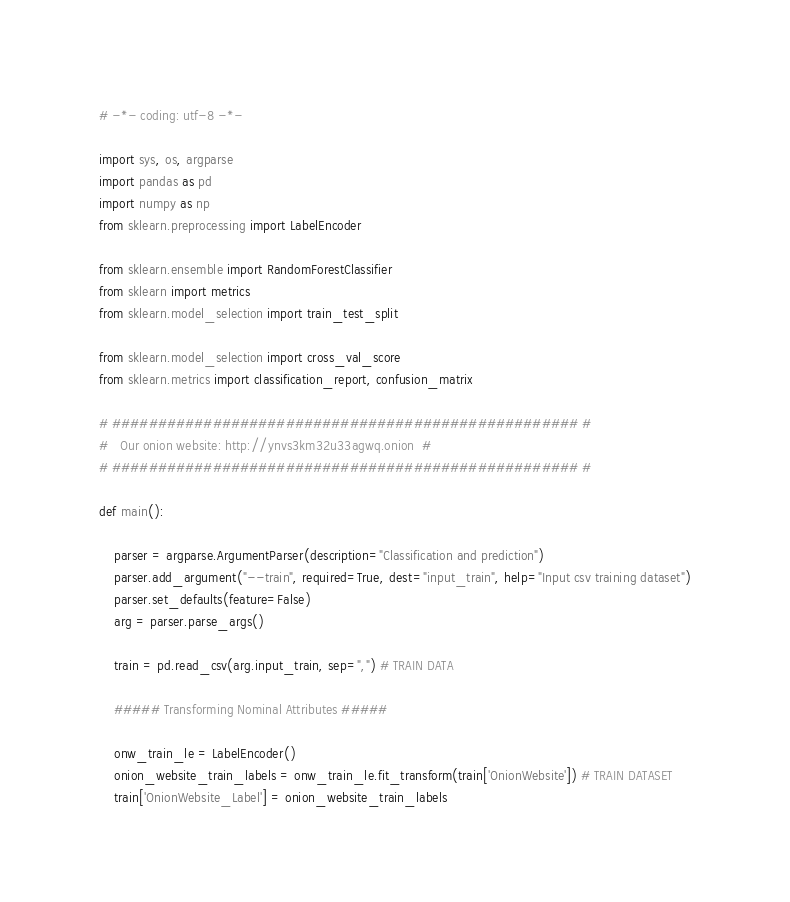Convert code to text. <code><loc_0><loc_0><loc_500><loc_500><_Python_># -*- coding: utf-8 -*-

import sys, os, argparse
import pandas as pd                     
import numpy as np
from sklearn.preprocessing import LabelEncoder

from sklearn.ensemble import RandomForestClassifier
from sklearn import metrics
from sklearn.model_selection import train_test_split

from sklearn.model_selection import cross_val_score
from sklearn.metrics import classification_report, confusion_matrix

# ################################################### #
#	Our onion website: http://ynvs3km32u33agwq.onion  #
# ################################################### #

def main(): 

	parser = argparse.ArgumentParser(description="Classification and prediction")
	parser.add_argument("--train", required=True, dest="input_train", help="Input csv training dataset")
	parser.set_defaults(feature=False)
	arg = parser.parse_args()

	train = pd.read_csv(arg.input_train, sep=",") # TRAIN DATA

	##### Transforming Nominal Attributes ##### 

	onw_train_le = LabelEncoder()
	onion_website_train_labels = onw_train_le.fit_transform(train['OnionWebsite']) # TRAIN DATASET
	train['OnionWebsite_Label'] = onion_website_train_labels 
</code> 